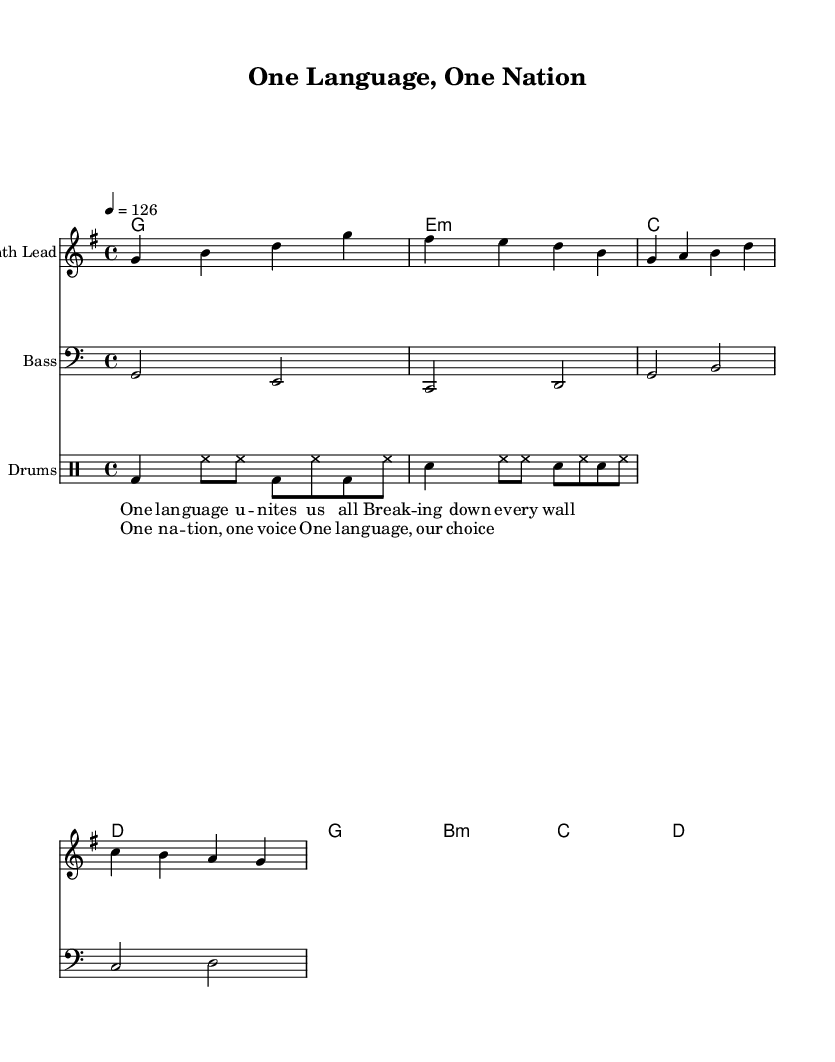What is the key signature of this music? The key signature is G major, which has one sharp (F#), indicated at the beginning of the staff.
Answer: G major What is the time signature of this music? The time signature is 4/4, which is typically notated at the beginning of the score.
Answer: 4/4 What is the tempo marking for this piece? The tempo marking is 126 beats per minute, indicated at the beginning of the score with "4 = 126".
Answer: 126 What chord follows the bass note "C"? The chord that follows the bass note "C" in the chord progression is D, which follows directly after the C chord in the sequence.
Answer: D How many measures are in the verse section? The verse section consists of 4 measures, as indicated by the notation of the lyrics under the melody.
Answer: 4 Which instrument plays the melody? The melody is played by the "Synth Lead," which is specified in the staff heading.
Answer: Synth Lead What lyrical theme is expressed in the chorus? The chorus emphasizes unity through the line "One language, our choice," promoting a message of togetherness.
Answer: Unity 